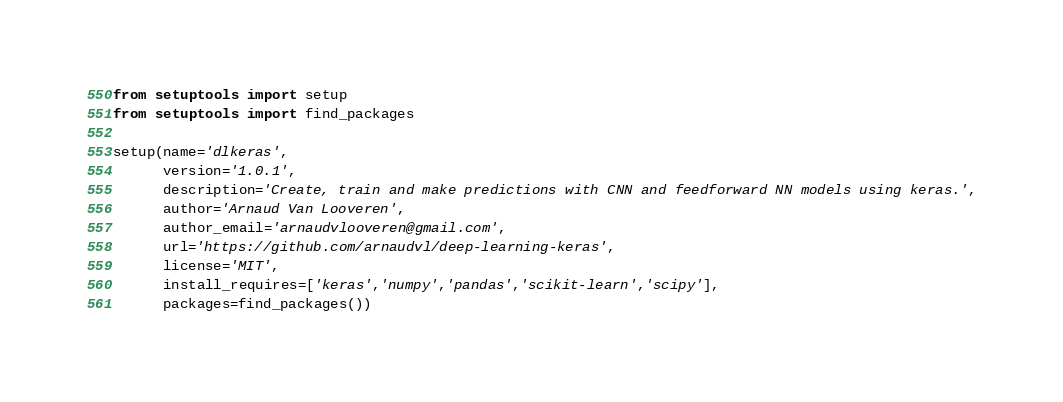<code> <loc_0><loc_0><loc_500><loc_500><_Python_>
from setuptools import setup
from setuptools import find_packages

setup(name='dlkeras',
      version='1.0.1',
      description='Create, train and make predictions with CNN and feedforward NN models using keras.',
      author='Arnaud Van Looveren',
      author_email='arnaudvlooveren@gmail.com',
      url='https://github.com/arnaudvl/deep-learning-keras',
      license='MIT',
      install_requires=['keras','numpy','pandas','scikit-learn','scipy'],
      packages=find_packages())
</code> 